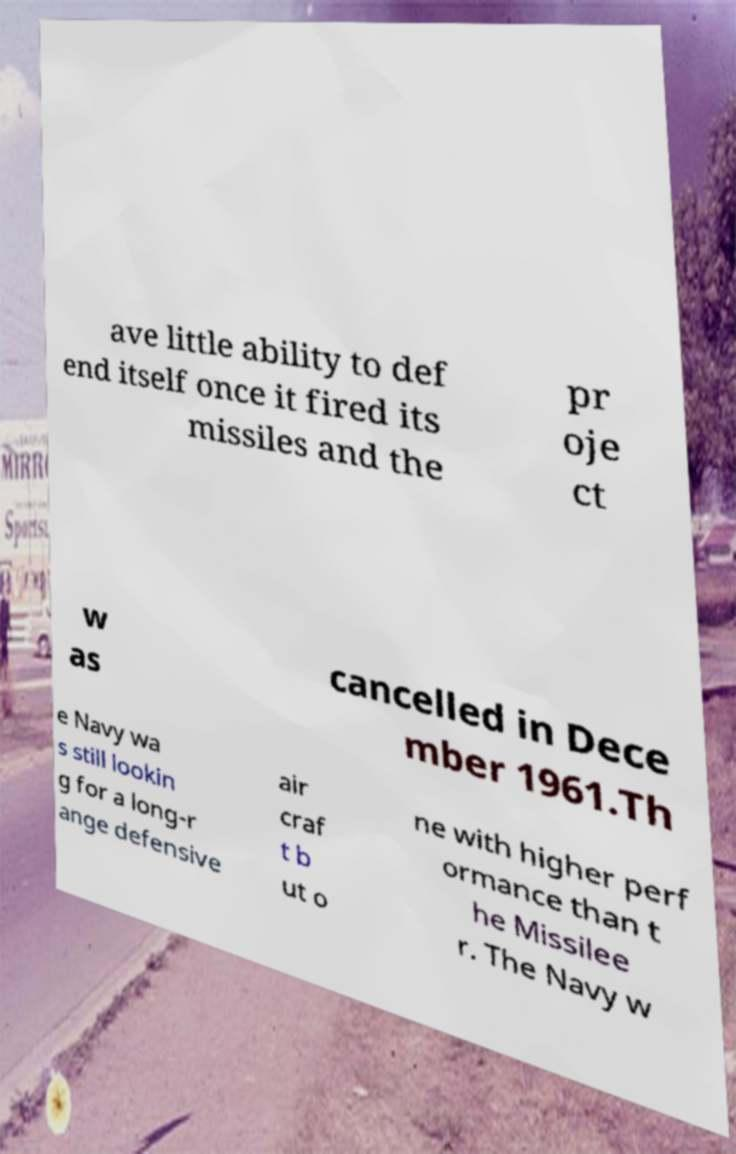There's text embedded in this image that I need extracted. Can you transcribe it verbatim? ave little ability to def end itself once it fired its missiles and the pr oje ct w as cancelled in Dece mber 1961.Th e Navy wa s still lookin g for a long-r ange defensive air craf t b ut o ne with higher perf ormance than t he Missilee r. The Navy w 